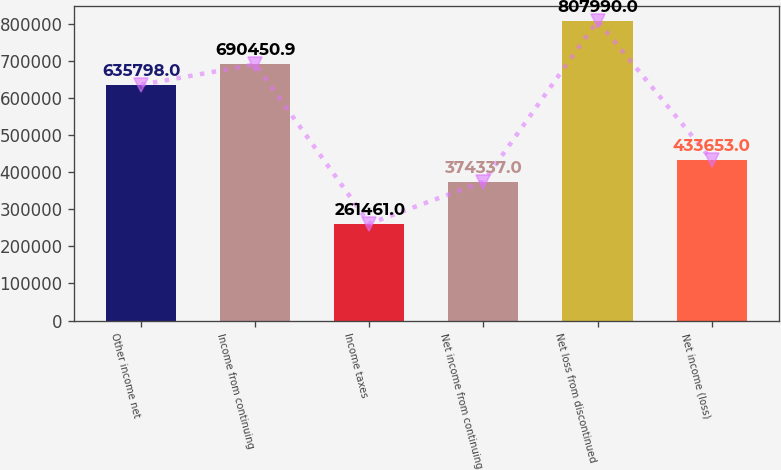Convert chart to OTSL. <chart><loc_0><loc_0><loc_500><loc_500><bar_chart><fcel>Other income net<fcel>Income from continuing<fcel>Income taxes<fcel>Net income from continuing<fcel>Net loss from discontinued<fcel>Net income (loss)<nl><fcel>635798<fcel>690451<fcel>261461<fcel>374337<fcel>807990<fcel>433653<nl></chart> 